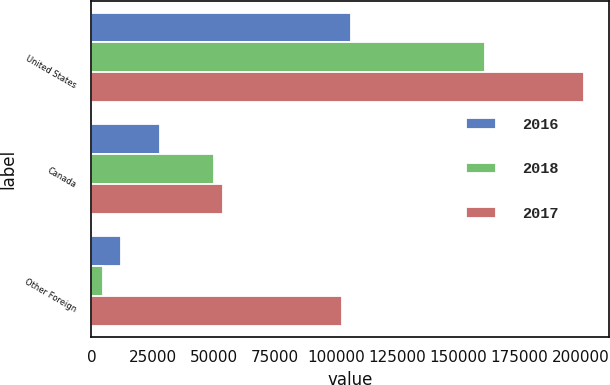Convert chart to OTSL. <chart><loc_0><loc_0><loc_500><loc_500><stacked_bar_chart><ecel><fcel>United States<fcel>Canada<fcel>Other Foreign<nl><fcel>2016<fcel>106223<fcel>28157<fcel>12264<nl><fcel>2018<fcel>161198<fcel>50019<fcel>4888<nl><fcel>2017<fcel>201730<fcel>53779<fcel>102402<nl></chart> 